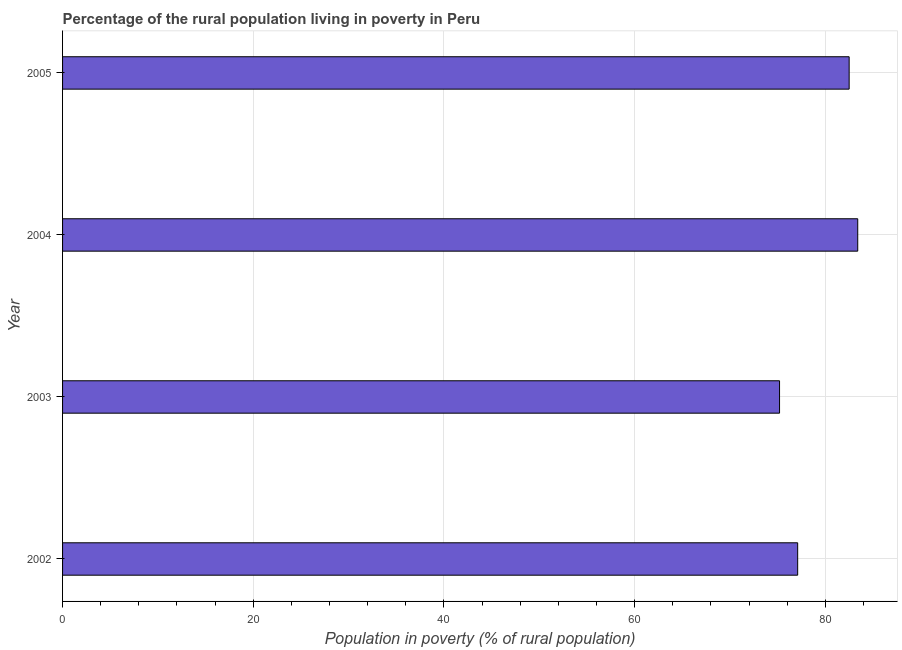Does the graph contain grids?
Your answer should be compact. Yes. What is the title of the graph?
Your answer should be compact. Percentage of the rural population living in poverty in Peru. What is the label or title of the X-axis?
Ensure brevity in your answer.  Population in poverty (% of rural population). What is the label or title of the Y-axis?
Provide a succinct answer. Year. What is the percentage of rural population living below poverty line in 2005?
Your answer should be compact. 82.5. Across all years, what is the maximum percentage of rural population living below poverty line?
Provide a succinct answer. 83.4. Across all years, what is the minimum percentage of rural population living below poverty line?
Make the answer very short. 75.2. What is the sum of the percentage of rural population living below poverty line?
Ensure brevity in your answer.  318.2. What is the difference between the percentage of rural population living below poverty line in 2003 and 2004?
Keep it short and to the point. -8.2. What is the average percentage of rural population living below poverty line per year?
Your answer should be compact. 79.55. What is the median percentage of rural population living below poverty line?
Your answer should be very brief. 79.8. In how many years, is the percentage of rural population living below poverty line greater than 56 %?
Give a very brief answer. 4. What is the ratio of the percentage of rural population living below poverty line in 2003 to that in 2005?
Keep it short and to the point. 0.91. Is the percentage of rural population living below poverty line in 2002 less than that in 2005?
Provide a short and direct response. Yes. Is the difference between the percentage of rural population living below poverty line in 2004 and 2005 greater than the difference between any two years?
Give a very brief answer. No. What is the difference between the highest and the second highest percentage of rural population living below poverty line?
Provide a succinct answer. 0.9. Is the sum of the percentage of rural population living below poverty line in 2002 and 2003 greater than the maximum percentage of rural population living below poverty line across all years?
Provide a succinct answer. Yes. In how many years, is the percentage of rural population living below poverty line greater than the average percentage of rural population living below poverty line taken over all years?
Provide a succinct answer. 2. How many bars are there?
Ensure brevity in your answer.  4. Are the values on the major ticks of X-axis written in scientific E-notation?
Offer a very short reply. No. What is the Population in poverty (% of rural population) of 2002?
Offer a very short reply. 77.1. What is the Population in poverty (% of rural population) of 2003?
Provide a short and direct response. 75.2. What is the Population in poverty (% of rural population) in 2004?
Offer a terse response. 83.4. What is the Population in poverty (% of rural population) of 2005?
Provide a succinct answer. 82.5. What is the difference between the Population in poverty (% of rural population) in 2002 and 2003?
Provide a short and direct response. 1.9. What is the difference between the Population in poverty (% of rural population) in 2002 and 2005?
Offer a terse response. -5.4. What is the difference between the Population in poverty (% of rural population) in 2003 and 2005?
Give a very brief answer. -7.3. What is the difference between the Population in poverty (% of rural population) in 2004 and 2005?
Provide a short and direct response. 0.9. What is the ratio of the Population in poverty (% of rural population) in 2002 to that in 2004?
Offer a terse response. 0.92. What is the ratio of the Population in poverty (% of rural population) in 2002 to that in 2005?
Provide a succinct answer. 0.94. What is the ratio of the Population in poverty (% of rural population) in 2003 to that in 2004?
Your answer should be compact. 0.9. What is the ratio of the Population in poverty (% of rural population) in 2003 to that in 2005?
Offer a very short reply. 0.91. 